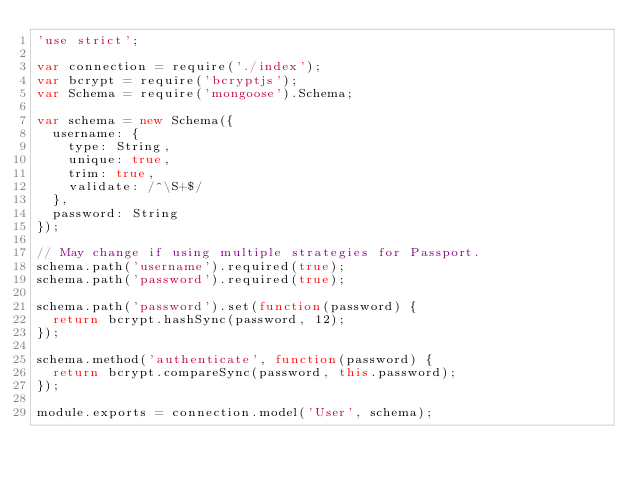<code> <loc_0><loc_0><loc_500><loc_500><_JavaScript_>'use strict';

var connection = require('./index');
var bcrypt = require('bcryptjs');
var Schema = require('mongoose').Schema;

var schema = new Schema({
  username: {
    type: String,
    unique: true,
    trim: true,
    validate: /^\S+$/
  },
  password: String
});

// May change if using multiple strategies for Passport.
schema.path('username').required(true);
schema.path('password').required(true);

schema.path('password').set(function(password) {
  return bcrypt.hashSync(password, 12);
});

schema.method('authenticate', function(password) {
  return bcrypt.compareSync(password, this.password);
});

module.exports = connection.model('User', schema);
</code> 